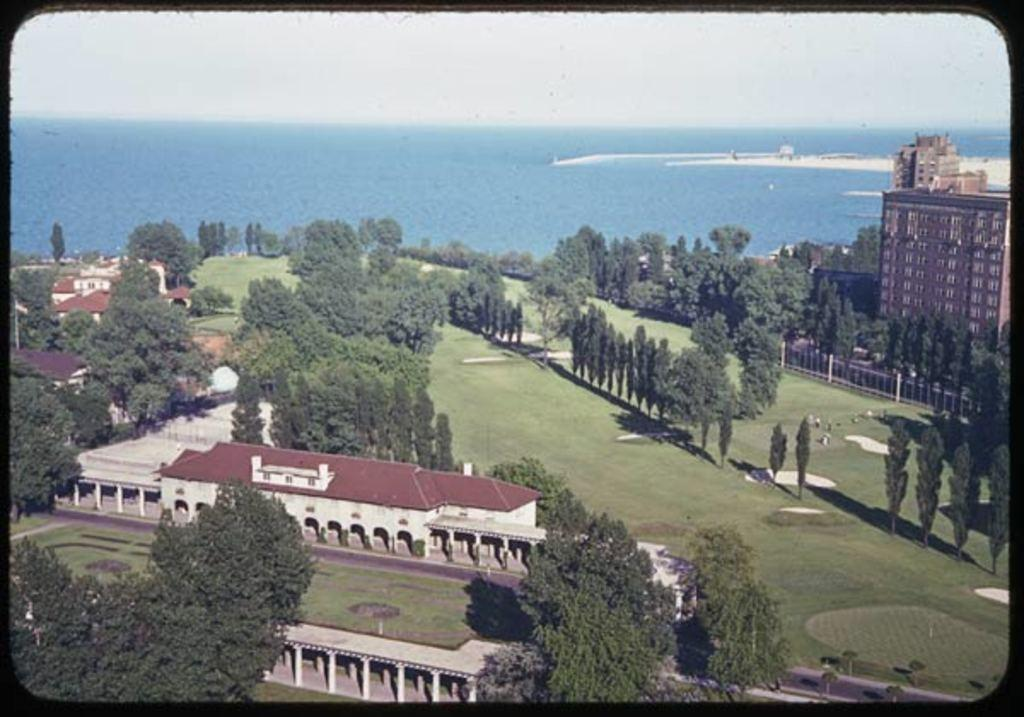What type of structures can be seen in the image? There are buildings in the image. What type of vegetation is present in the image? There are trees and grass in the image. What natural element is visible in the image? There is water visible in the image. What type of credit can be seen being used in the image? There is no credit being used in the image; it features buildings, trees, grass, and water. What type of trousers are the trees wearing in the image? Trees do not wear trousers, as they are plants and not human beings. 